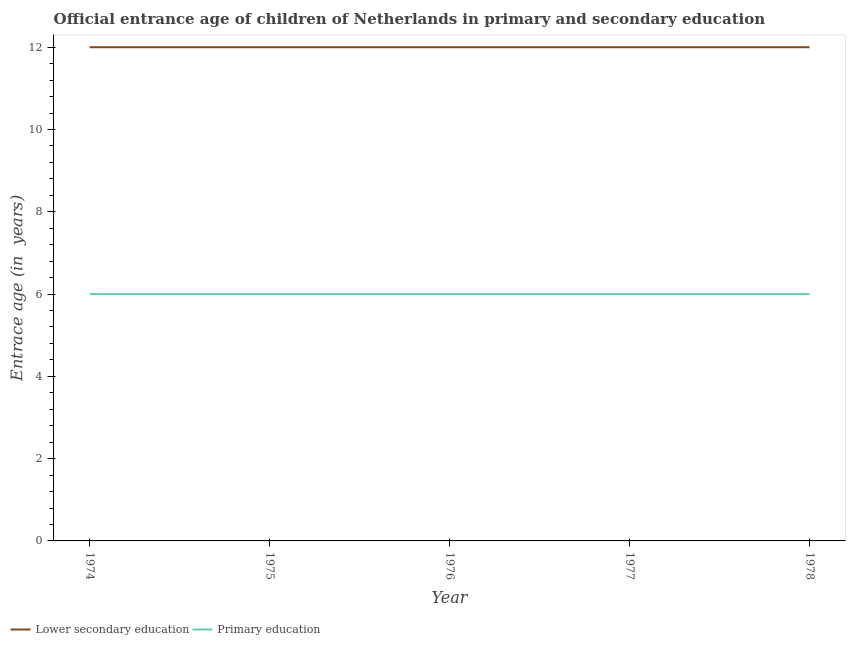Does the line corresponding to entrance age of chiildren in primary education intersect with the line corresponding to entrance age of children in lower secondary education?
Your response must be concise. No. What is the entrance age of children in lower secondary education in 1978?
Make the answer very short. 12. Across all years, what is the maximum entrance age of chiildren in primary education?
Give a very brief answer. 6. Across all years, what is the minimum entrance age of chiildren in primary education?
Make the answer very short. 6. In which year was the entrance age of chiildren in primary education maximum?
Your answer should be very brief. 1974. In which year was the entrance age of children in lower secondary education minimum?
Ensure brevity in your answer.  1974. What is the total entrance age of children in lower secondary education in the graph?
Keep it short and to the point. 60. What is the difference between the entrance age of chiildren in primary education in 1978 and the entrance age of children in lower secondary education in 1977?
Ensure brevity in your answer.  -6. In the year 1974, what is the difference between the entrance age of children in lower secondary education and entrance age of chiildren in primary education?
Give a very brief answer. 6. In how many years, is the entrance age of chiildren in primary education greater than 10.8 years?
Provide a succinct answer. 0. What is the ratio of the entrance age of chiildren in primary education in 1974 to that in 1977?
Make the answer very short. 1. Is the difference between the entrance age of chiildren in primary education in 1975 and 1978 greater than the difference between the entrance age of children in lower secondary education in 1975 and 1978?
Offer a terse response. No. In how many years, is the entrance age of children in lower secondary education greater than the average entrance age of children in lower secondary education taken over all years?
Your response must be concise. 0. Is the sum of the entrance age of chiildren in primary education in 1974 and 1976 greater than the maximum entrance age of children in lower secondary education across all years?
Ensure brevity in your answer.  No. Does the entrance age of chiildren in primary education monotonically increase over the years?
Your response must be concise. No. Is the entrance age of chiildren in primary education strictly less than the entrance age of children in lower secondary education over the years?
Your response must be concise. Yes. How many lines are there?
Offer a terse response. 2. Does the graph contain grids?
Ensure brevity in your answer.  No. Where does the legend appear in the graph?
Make the answer very short. Bottom left. How are the legend labels stacked?
Your answer should be very brief. Horizontal. What is the title of the graph?
Your answer should be compact. Official entrance age of children of Netherlands in primary and secondary education. Does "Public funds" appear as one of the legend labels in the graph?
Ensure brevity in your answer.  No. What is the label or title of the Y-axis?
Keep it short and to the point. Entrace age (in  years). What is the Entrace age (in  years) of Lower secondary education in 1974?
Provide a succinct answer. 12. What is the Entrace age (in  years) of Primary education in 1974?
Give a very brief answer. 6. What is the Entrace age (in  years) in Lower secondary education in 1977?
Keep it short and to the point. 12. What is the Entrace age (in  years) in Primary education in 1977?
Your response must be concise. 6. What is the Entrace age (in  years) in Lower secondary education in 1978?
Ensure brevity in your answer.  12. What is the Entrace age (in  years) in Primary education in 1978?
Make the answer very short. 6. Across all years, what is the minimum Entrace age (in  years) of Lower secondary education?
Make the answer very short. 12. What is the total Entrace age (in  years) of Lower secondary education in the graph?
Ensure brevity in your answer.  60. What is the total Entrace age (in  years) of Primary education in the graph?
Your answer should be very brief. 30. What is the difference between the Entrace age (in  years) in Lower secondary education in 1974 and that in 1976?
Provide a succinct answer. 0. What is the difference between the Entrace age (in  years) in Primary education in 1974 and that in 1976?
Ensure brevity in your answer.  0. What is the difference between the Entrace age (in  years) in Primary education in 1974 and that in 1978?
Provide a short and direct response. 0. What is the difference between the Entrace age (in  years) in Primary education in 1975 and that in 1977?
Give a very brief answer. 0. What is the difference between the Entrace age (in  years) in Lower secondary education in 1975 and that in 1978?
Keep it short and to the point. 0. What is the difference between the Entrace age (in  years) in Primary education in 1975 and that in 1978?
Provide a succinct answer. 0. What is the difference between the Entrace age (in  years) in Lower secondary education in 1976 and that in 1977?
Your answer should be very brief. 0. What is the difference between the Entrace age (in  years) in Primary education in 1976 and that in 1977?
Ensure brevity in your answer.  0. What is the difference between the Entrace age (in  years) in Lower secondary education in 1977 and that in 1978?
Provide a short and direct response. 0. What is the difference between the Entrace age (in  years) in Primary education in 1977 and that in 1978?
Offer a very short reply. 0. What is the difference between the Entrace age (in  years) in Lower secondary education in 1974 and the Entrace age (in  years) in Primary education in 1976?
Your answer should be compact. 6. What is the difference between the Entrace age (in  years) of Lower secondary education in 1974 and the Entrace age (in  years) of Primary education in 1977?
Offer a very short reply. 6. What is the difference between the Entrace age (in  years) in Lower secondary education in 1976 and the Entrace age (in  years) in Primary education in 1978?
Keep it short and to the point. 6. What is the difference between the Entrace age (in  years) in Lower secondary education in 1977 and the Entrace age (in  years) in Primary education in 1978?
Provide a short and direct response. 6. In the year 1975, what is the difference between the Entrace age (in  years) in Lower secondary education and Entrace age (in  years) in Primary education?
Make the answer very short. 6. In the year 1976, what is the difference between the Entrace age (in  years) in Lower secondary education and Entrace age (in  years) in Primary education?
Provide a short and direct response. 6. What is the ratio of the Entrace age (in  years) in Lower secondary education in 1974 to that in 1975?
Give a very brief answer. 1. What is the ratio of the Entrace age (in  years) of Lower secondary education in 1974 to that in 1977?
Offer a very short reply. 1. What is the ratio of the Entrace age (in  years) in Primary education in 1974 to that in 1977?
Give a very brief answer. 1. What is the ratio of the Entrace age (in  years) in Primary education in 1974 to that in 1978?
Keep it short and to the point. 1. What is the ratio of the Entrace age (in  years) of Primary education in 1975 to that in 1976?
Your response must be concise. 1. What is the ratio of the Entrace age (in  years) in Primary education in 1975 to that in 1977?
Offer a very short reply. 1. What is the ratio of the Entrace age (in  years) of Primary education in 1975 to that in 1978?
Provide a short and direct response. 1. What is the ratio of the Entrace age (in  years) of Lower secondary education in 1977 to that in 1978?
Keep it short and to the point. 1. What is the ratio of the Entrace age (in  years) in Primary education in 1977 to that in 1978?
Give a very brief answer. 1. What is the difference between the highest and the second highest Entrace age (in  years) in Primary education?
Ensure brevity in your answer.  0. What is the difference between the highest and the lowest Entrace age (in  years) of Primary education?
Offer a very short reply. 0. 